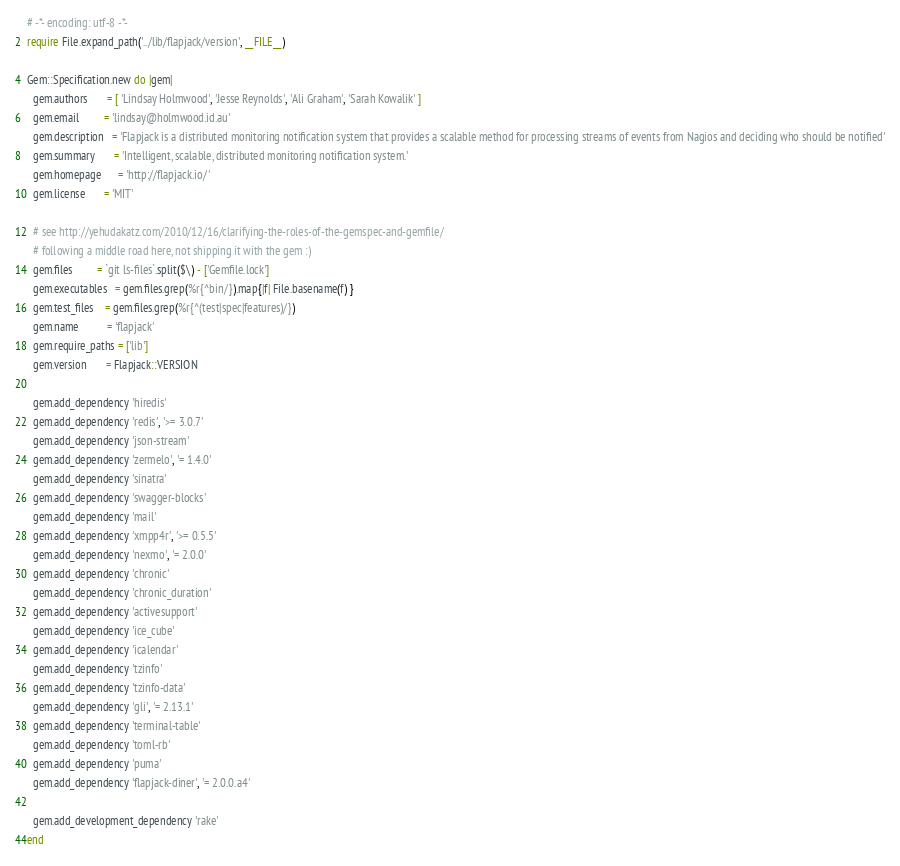<code> <loc_0><loc_0><loc_500><loc_500><_Ruby_># -*- encoding: utf-8 -*-
require File.expand_path('../lib/flapjack/version', __FILE__)

Gem::Specification.new do |gem|
  gem.authors       = [ 'Lindsay Holmwood', 'Jesse Reynolds', 'Ali Graham', 'Sarah Kowalik' ]
  gem.email         = 'lindsay@holmwood.id.au'
  gem.description   = 'Flapjack is a distributed monitoring notification system that provides a scalable method for processing streams of events from Nagios and deciding who should be notified'
  gem.summary       = 'Intelligent, scalable, distributed monitoring notification system.'
  gem.homepage      = 'http://flapjack.io/'
  gem.license       = 'MIT'

  # see http://yehudakatz.com/2010/12/16/clarifying-the-roles-of-the-gemspec-and-gemfile/
  # following a middle road here, not shipping it with the gem :)
  gem.files         = `git ls-files`.split($\) - ['Gemfile.lock']
  gem.executables   = gem.files.grep(%r{^bin/}).map{|f| File.basename(f) }
  gem.test_files    = gem.files.grep(%r{^(test|spec|features)/})
  gem.name          = 'flapjack'
  gem.require_paths = ['lib']
  gem.version       = Flapjack::VERSION

  gem.add_dependency 'hiredis'
  gem.add_dependency 'redis', '>= 3.0.7'
  gem.add_dependency 'json-stream'
  gem.add_dependency 'zermelo', '= 1.4.0'
  gem.add_dependency 'sinatra'
  gem.add_dependency 'swagger-blocks'
  gem.add_dependency 'mail'
  gem.add_dependency 'xmpp4r', '>= 0.5.5'
  gem.add_dependency 'nexmo', '= 2.0.0'
  gem.add_dependency 'chronic'
  gem.add_dependency 'chronic_duration'
  gem.add_dependency 'activesupport'
  gem.add_dependency 'ice_cube'
  gem.add_dependency 'icalendar'
  gem.add_dependency 'tzinfo'
  gem.add_dependency 'tzinfo-data'
  gem.add_dependency 'gli', '= 2.13.1'
  gem.add_dependency 'terminal-table'
  gem.add_dependency 'toml-rb'
  gem.add_dependency 'puma'
  gem.add_dependency 'flapjack-diner', '= 2.0.0.a4'

  gem.add_development_dependency 'rake'
end
</code> 